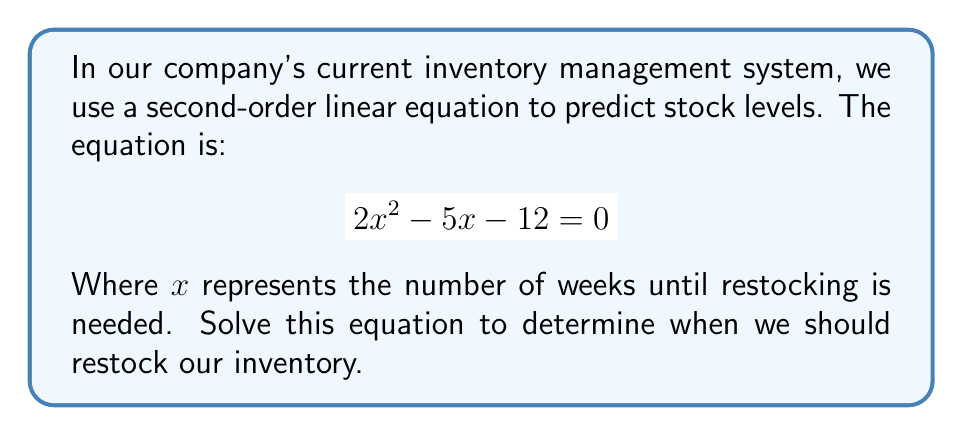Teach me how to tackle this problem. To solve this second-order linear equation, we'll use the quadratic formula:

$$x = \frac{-b \pm \sqrt{b^2 - 4ac}}{2a}$$

Where $a = 2$, $b = -5$, and $c = -12$

Step 1: Substitute the values into the quadratic formula:
$$x = \frac{-(-5) \pm \sqrt{(-5)^2 - 4(2)(-12)}}{2(2)}$$

Step 2: Simplify under the square root:
$$x = \frac{5 \pm \sqrt{25 + 96}}{4} = \frac{5 \pm \sqrt{121}}{4}$$

Step 3: Simplify the square root:
$$x = \frac{5 \pm 11}{4}$$

Step 4: Solve for both positive and negative cases:
$$x = \frac{5 + 11}{4} = \frac{16}{4} = 4$$
$$x = \frac{5 - 11}{4} = \frac{-6}{4} = -1.5$$

Step 5: Interpret the results:
Since we're dealing with weeks, we can discard the negative solution. Therefore, we should restock in 4 weeks.
Answer: $x = 4$ weeks 